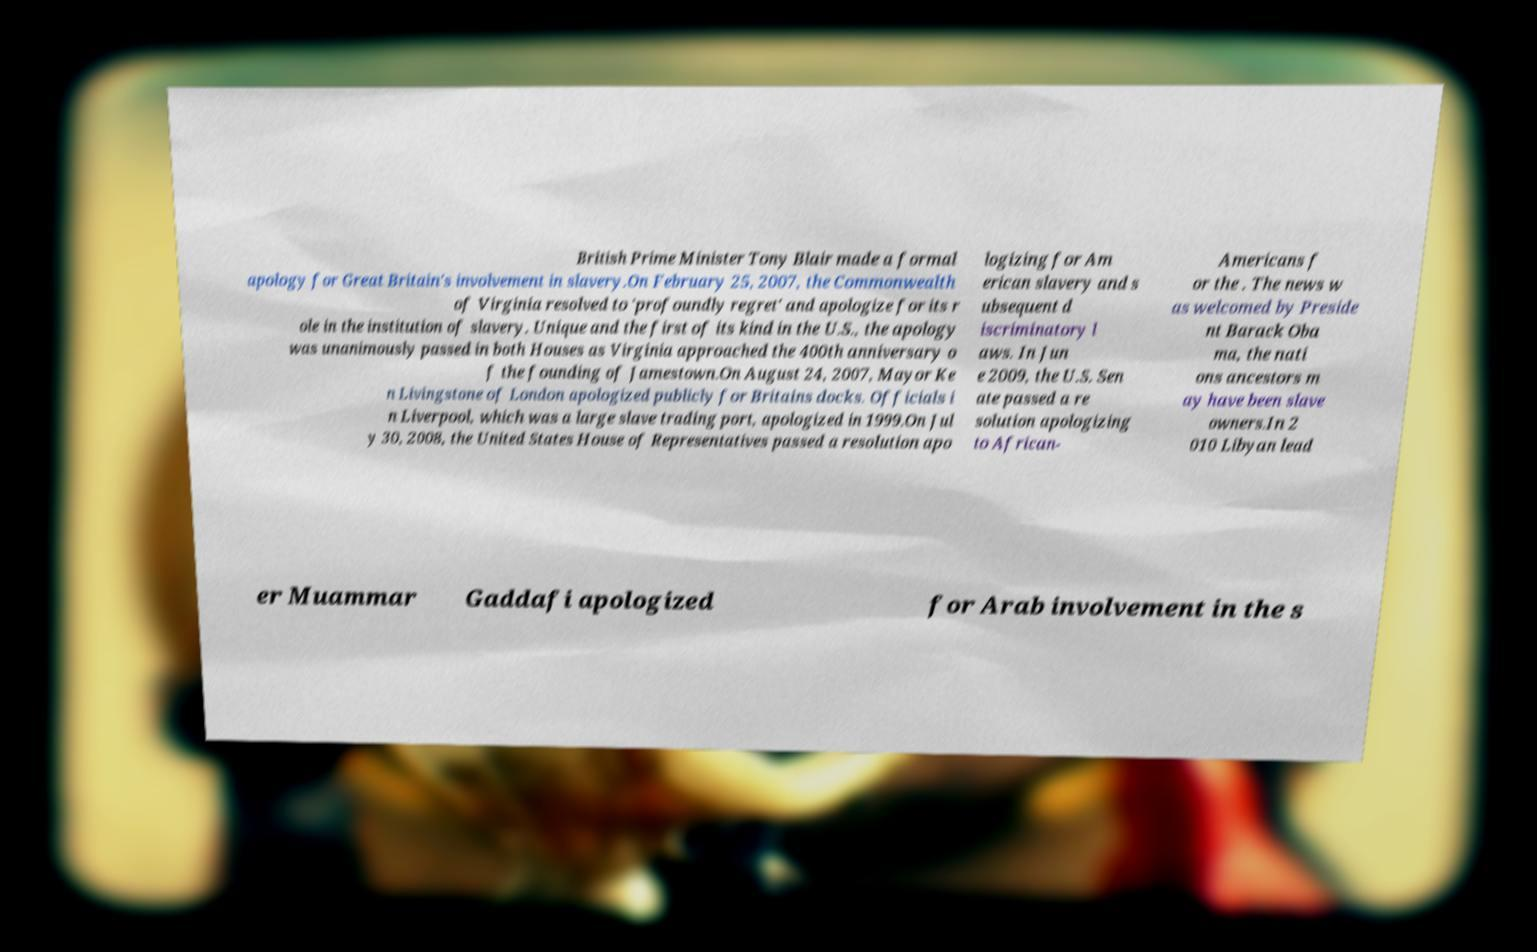Could you extract and type out the text from this image? British Prime Minister Tony Blair made a formal apology for Great Britain's involvement in slavery.On February 25, 2007, the Commonwealth of Virginia resolved to 'profoundly regret' and apologize for its r ole in the institution of slavery. Unique and the first of its kind in the U.S., the apology was unanimously passed in both Houses as Virginia approached the 400th anniversary o f the founding of Jamestown.On August 24, 2007, Mayor Ke n Livingstone of London apologized publicly for Britains docks. Officials i n Liverpool, which was a large slave trading port, apologized in 1999.On Jul y 30, 2008, the United States House of Representatives passed a resolution apo logizing for Am erican slavery and s ubsequent d iscriminatory l aws. In Jun e 2009, the U.S. Sen ate passed a re solution apologizing to African- Americans f or the . The news w as welcomed by Preside nt Barack Oba ma, the nati ons ancestors m ay have been slave owners.In 2 010 Libyan lead er Muammar Gaddafi apologized for Arab involvement in the s 